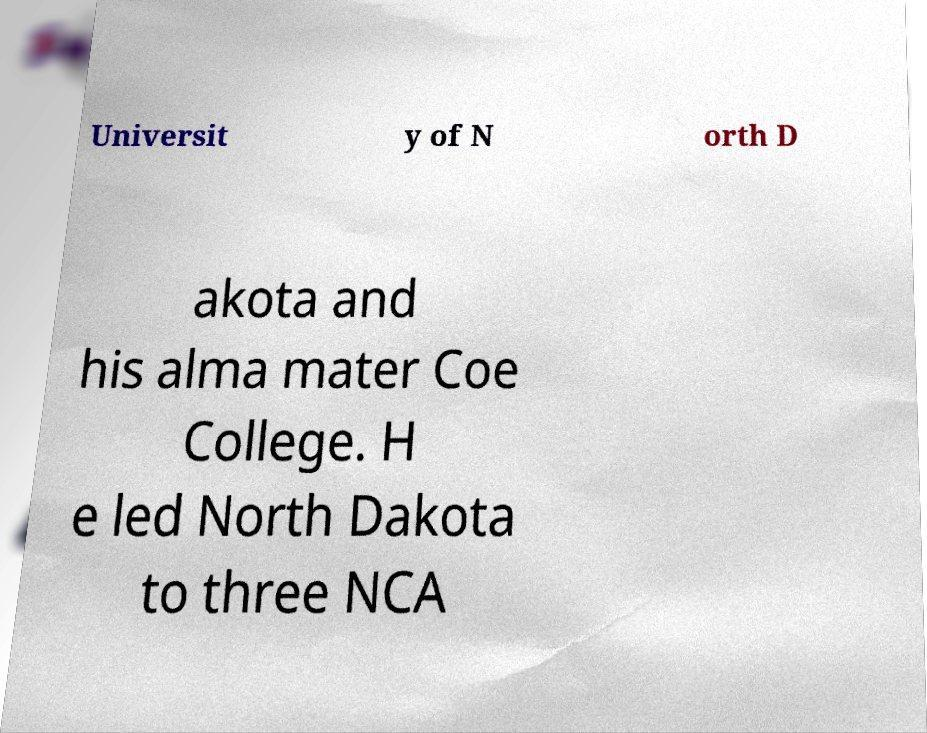Can you read and provide the text displayed in the image?This photo seems to have some interesting text. Can you extract and type it out for me? Universit y of N orth D akota and his alma mater Coe College. H e led North Dakota to three NCA 